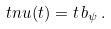<formula> <loc_0><loc_0><loc_500><loc_500>\ t n u ( t ) = t \, b _ { \psi } \, .</formula> 